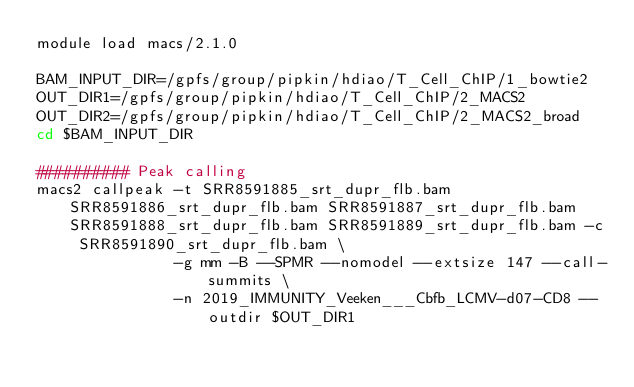Convert code to text. <code><loc_0><loc_0><loc_500><loc_500><_Bash_>module load macs/2.1.0

BAM_INPUT_DIR=/gpfs/group/pipkin/hdiao/T_Cell_ChIP/1_bowtie2
OUT_DIR1=/gpfs/group/pipkin/hdiao/T_Cell_ChIP/2_MACS2
OUT_DIR2=/gpfs/group/pipkin/hdiao/T_Cell_ChIP/2_MACS2_broad
cd $BAM_INPUT_DIR

########## Peak calling
macs2 callpeak -t SRR8591885_srt_dupr_flb.bam SRR8591886_srt_dupr_flb.bam SRR8591887_srt_dupr_flb.bam SRR8591888_srt_dupr_flb.bam SRR8591889_srt_dupr_flb.bam -c SRR8591890_srt_dupr_flb.bam \
               -g mm -B --SPMR --nomodel --extsize 147 --call-summits \
               -n 2019_IMMUNITY_Veeken___Cbfb_LCMV-d07-CD8 --outdir $OUT_DIR1
</code> 